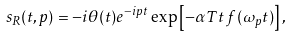Convert formula to latex. <formula><loc_0><loc_0><loc_500><loc_500>s _ { R } ( t , p ) = - i \theta ( t ) e ^ { - i p t } \exp \left [ - \alpha T t \, f ( \omega _ { p } t ) \right ] ,</formula> 